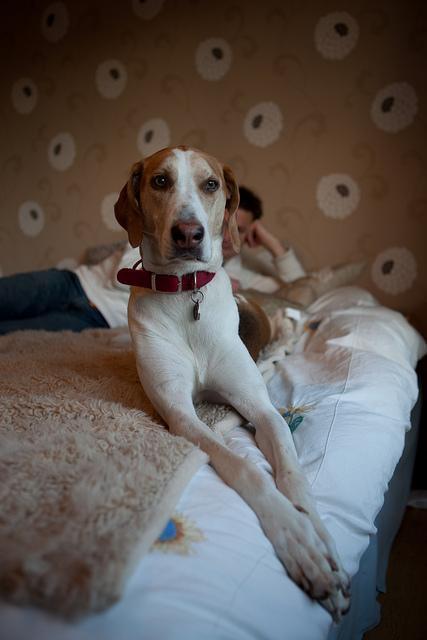How many beds are in the photo?
Give a very brief answer. 2. How many people are in the photo?
Give a very brief answer. 2. 